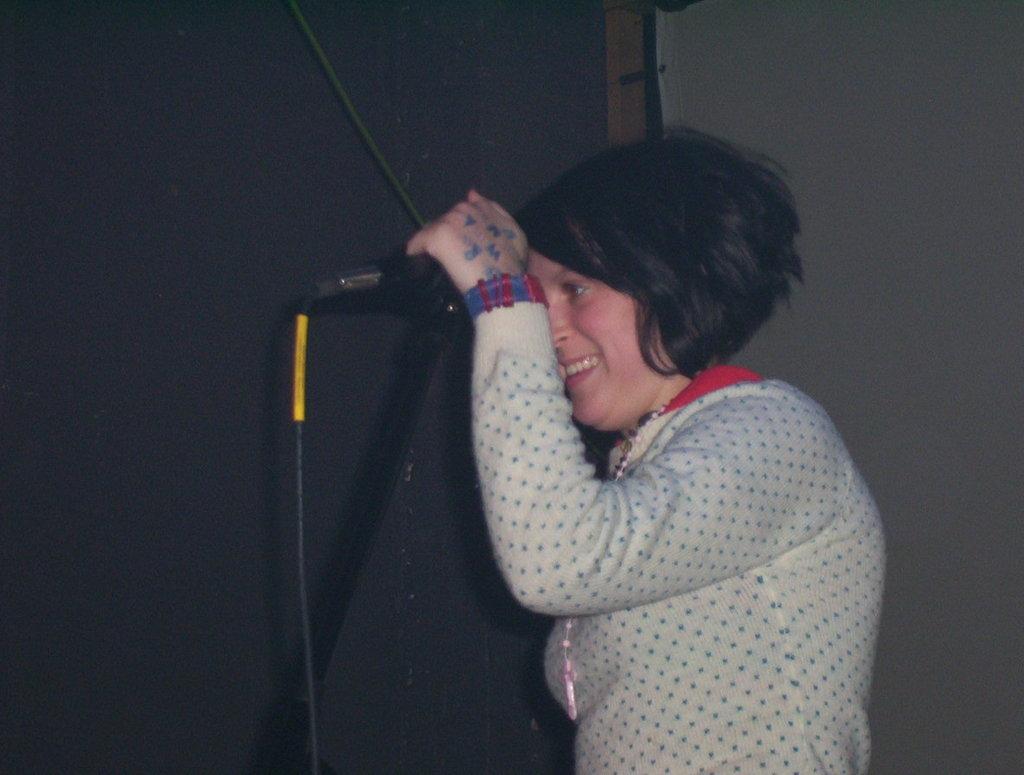Can you describe this image briefly? In this image I can see a woman standing in front of a mike I can see a wall behind her. 